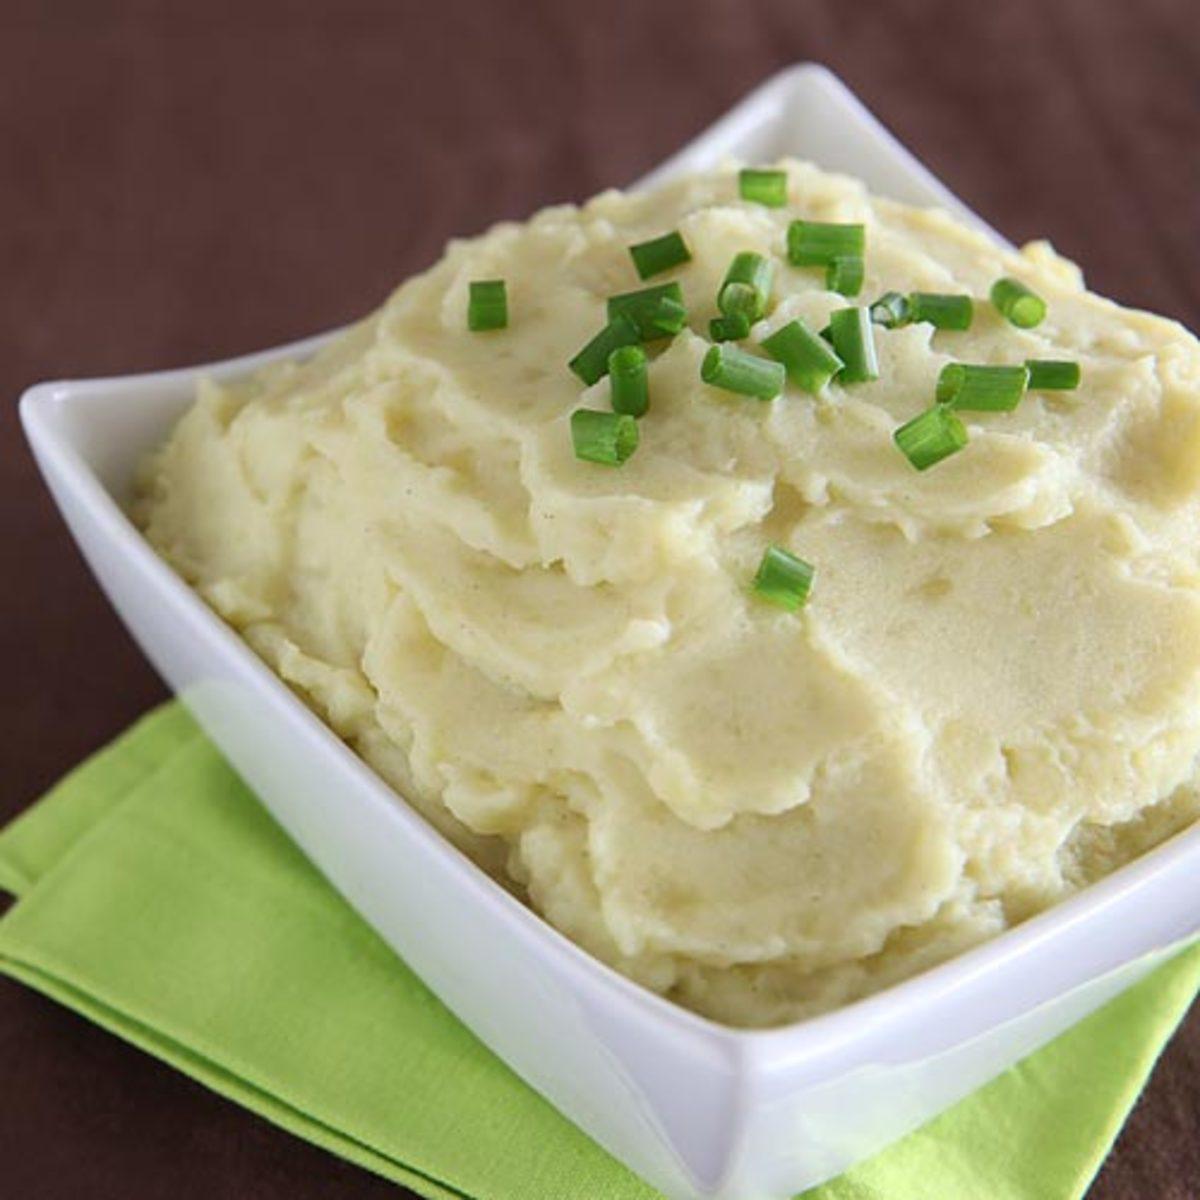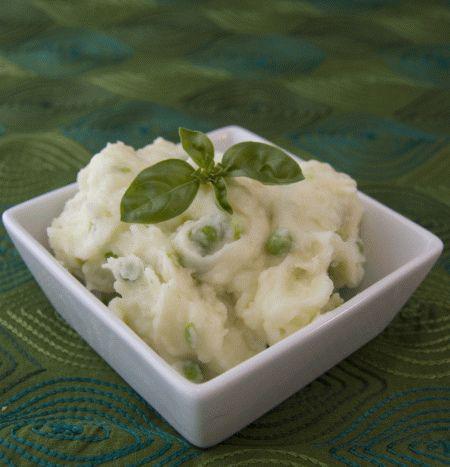The first image is the image on the left, the second image is the image on the right. For the images displayed, is the sentence "Green garnishes are sprinkled over both dishes." factually correct? Answer yes or no. Yes. The first image is the image on the left, the second image is the image on the right. Considering the images on both sides, is "Left image shows food served in a white, non-square dish with textured design." valid? Answer yes or no. No. 